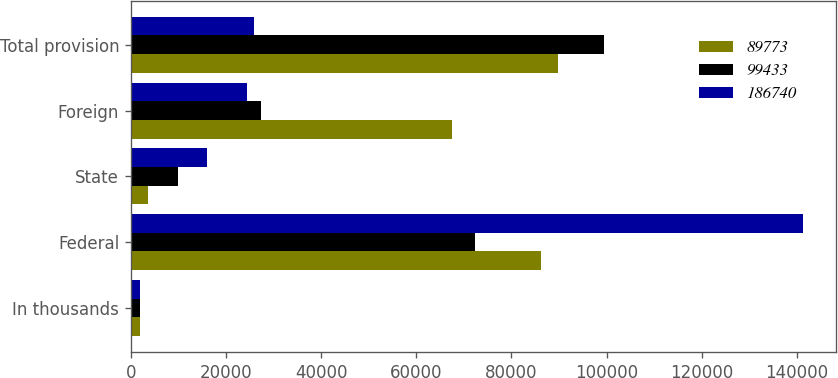<chart> <loc_0><loc_0><loc_500><loc_500><stacked_bar_chart><ecel><fcel>In thousands<fcel>Federal<fcel>State<fcel>Foreign<fcel>Total provision<nl><fcel>89773<fcel>2017<fcel>86157<fcel>3644<fcel>67395<fcel>89773<nl><fcel>99433<fcel>2016<fcel>72317<fcel>9953<fcel>27391<fcel>99433<nl><fcel>186740<fcel>2015<fcel>141245<fcel>16072<fcel>24442<fcel>25916.5<nl></chart> 